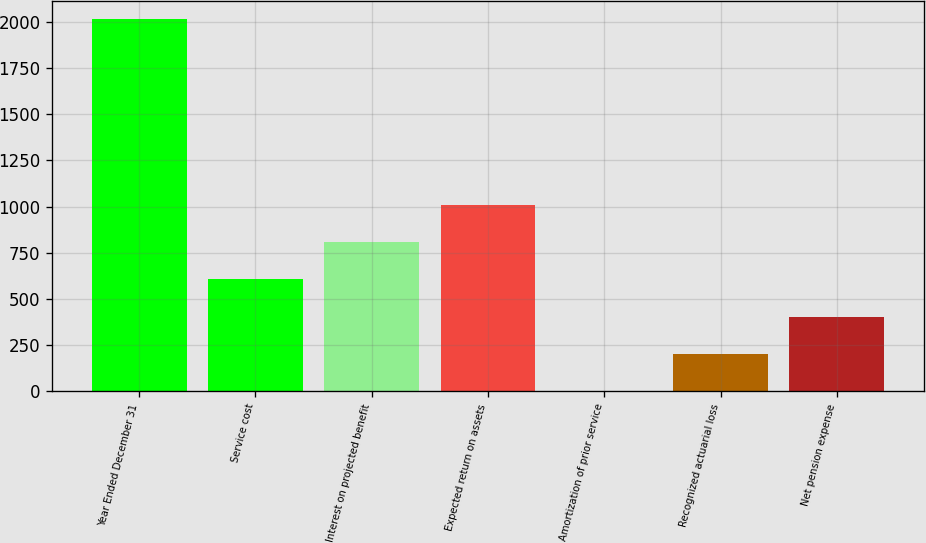Convert chart to OTSL. <chart><loc_0><loc_0><loc_500><loc_500><bar_chart><fcel>Year Ended December 31<fcel>Service cost<fcel>Interest on projected benefit<fcel>Expected return on assets<fcel>Amortization of prior service<fcel>Recognized actuarial loss<fcel>Net pension expense<nl><fcel>2016<fcel>605.64<fcel>807.12<fcel>1008.6<fcel>1.2<fcel>202.68<fcel>404.16<nl></chart> 